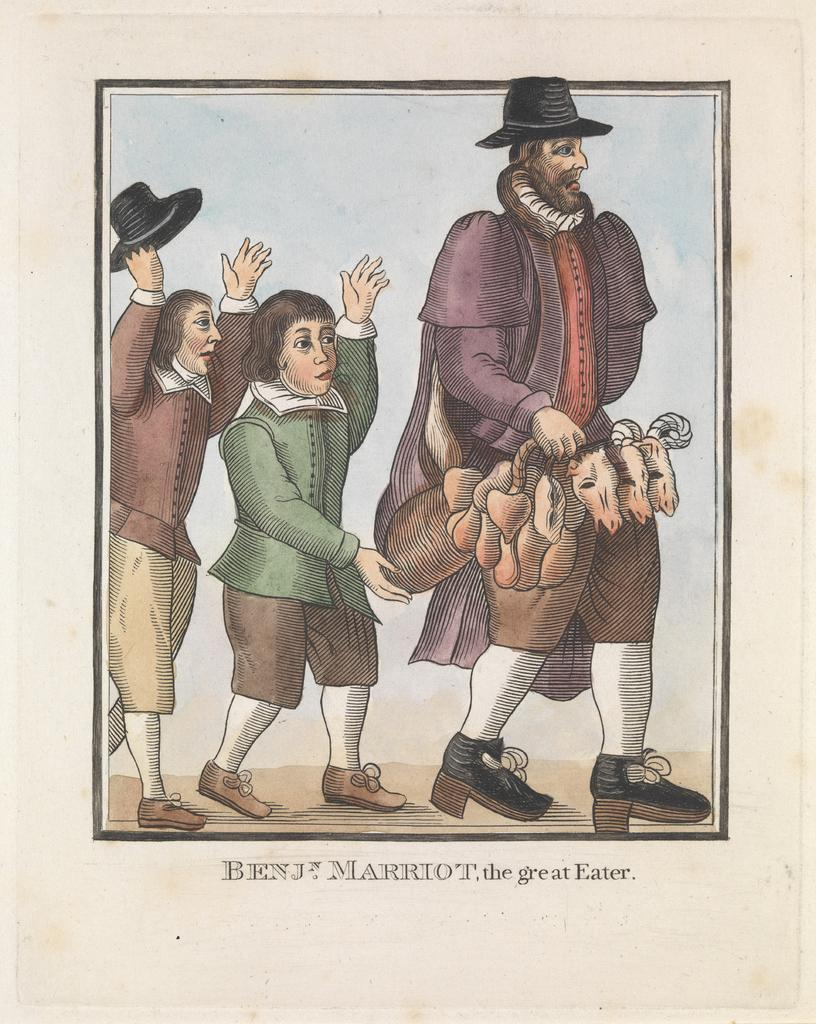How many people are in the image? There are three persons walking in the image. Can you describe the clothing of one of the persons? One person is wearing a green and brown color dress. What is the color of the background in the image? The background of the image is white. What type of yam is being held by one of the persons in the image? There is no yam present in the image; the persons are walking and not holding any objects. What time does the clock in the image show? There is no clock present in the image. 